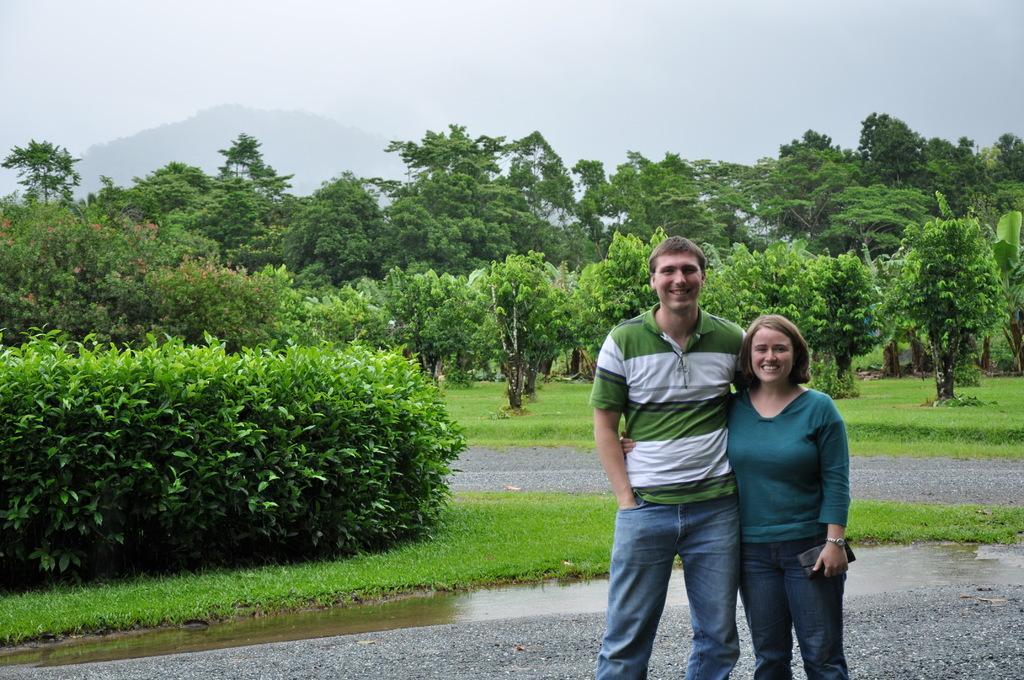How would you summarize this image in a sentence or two? In the image there are two people standing and posing for the photo and behind them there are many trees, plants and a a lot of grass surface. 